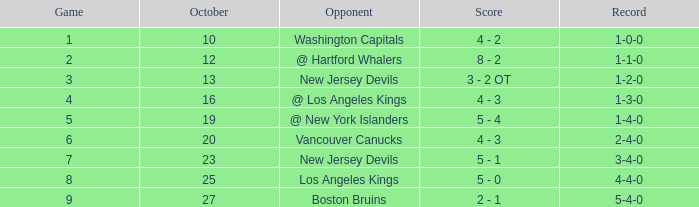Which game has the top score in october with 9? 27.0. 